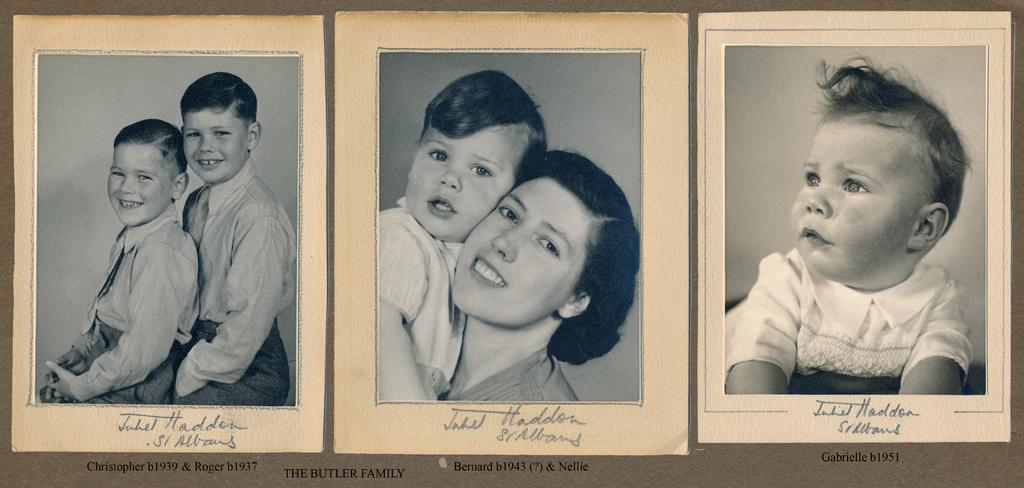How many black and white pictures are in the image? There are three black and white pictures in the image. What is depicted in the rightmost picture? In the rightmost picture, there is a baby. What is happening in the middle picture? In the middle picture, a woman is holding a baby. What can be seen in the leftmost picture? In the leftmost picture, there are two boys. What is the emotional state of the two boys in the leftmost picture? The two boys are smiling. What type of drink is being served in the middle picture? There is no drink present in the middle picture, as it features a woman holding a baby. Can you see a zipper on the baby's clothing in the rightmost picture? There is no zipper visible on the baby's clothing in the rightmost picture, as the focus is on the baby itself. 